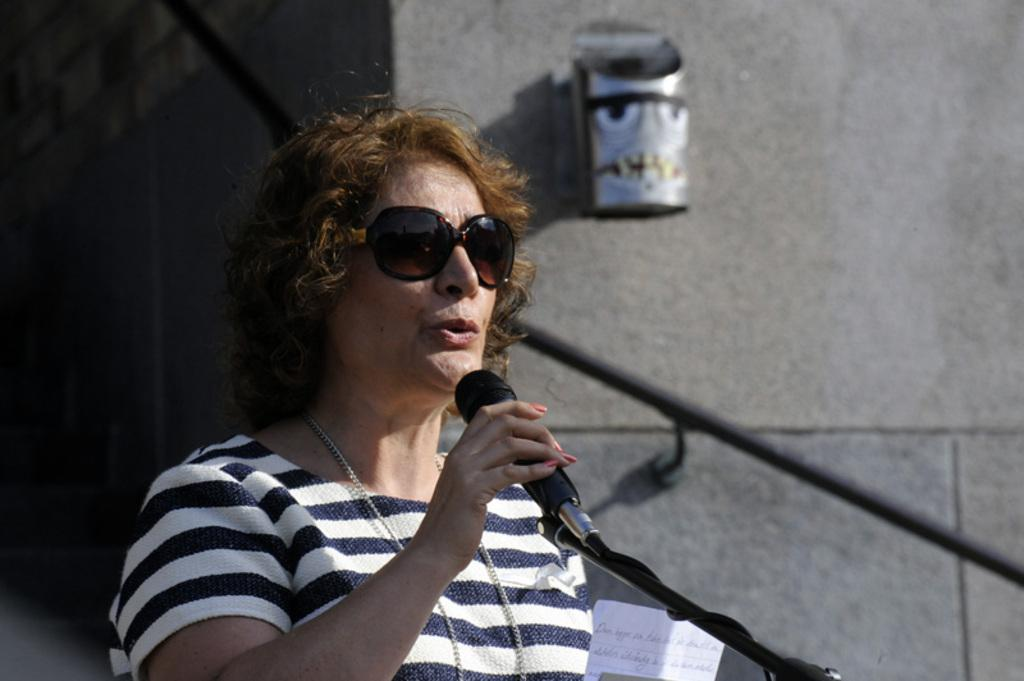Who is the main subject in the image? There is a woman in the image. What is the woman holding in her hand? The woman is holding a microphone in her hand. What is the woman doing with the microphone? The woman is speaking into the microphone. What type of blade is the woman using to cut the microphone in the image? There is no blade present in the image, nor is the woman cutting the microphone. 